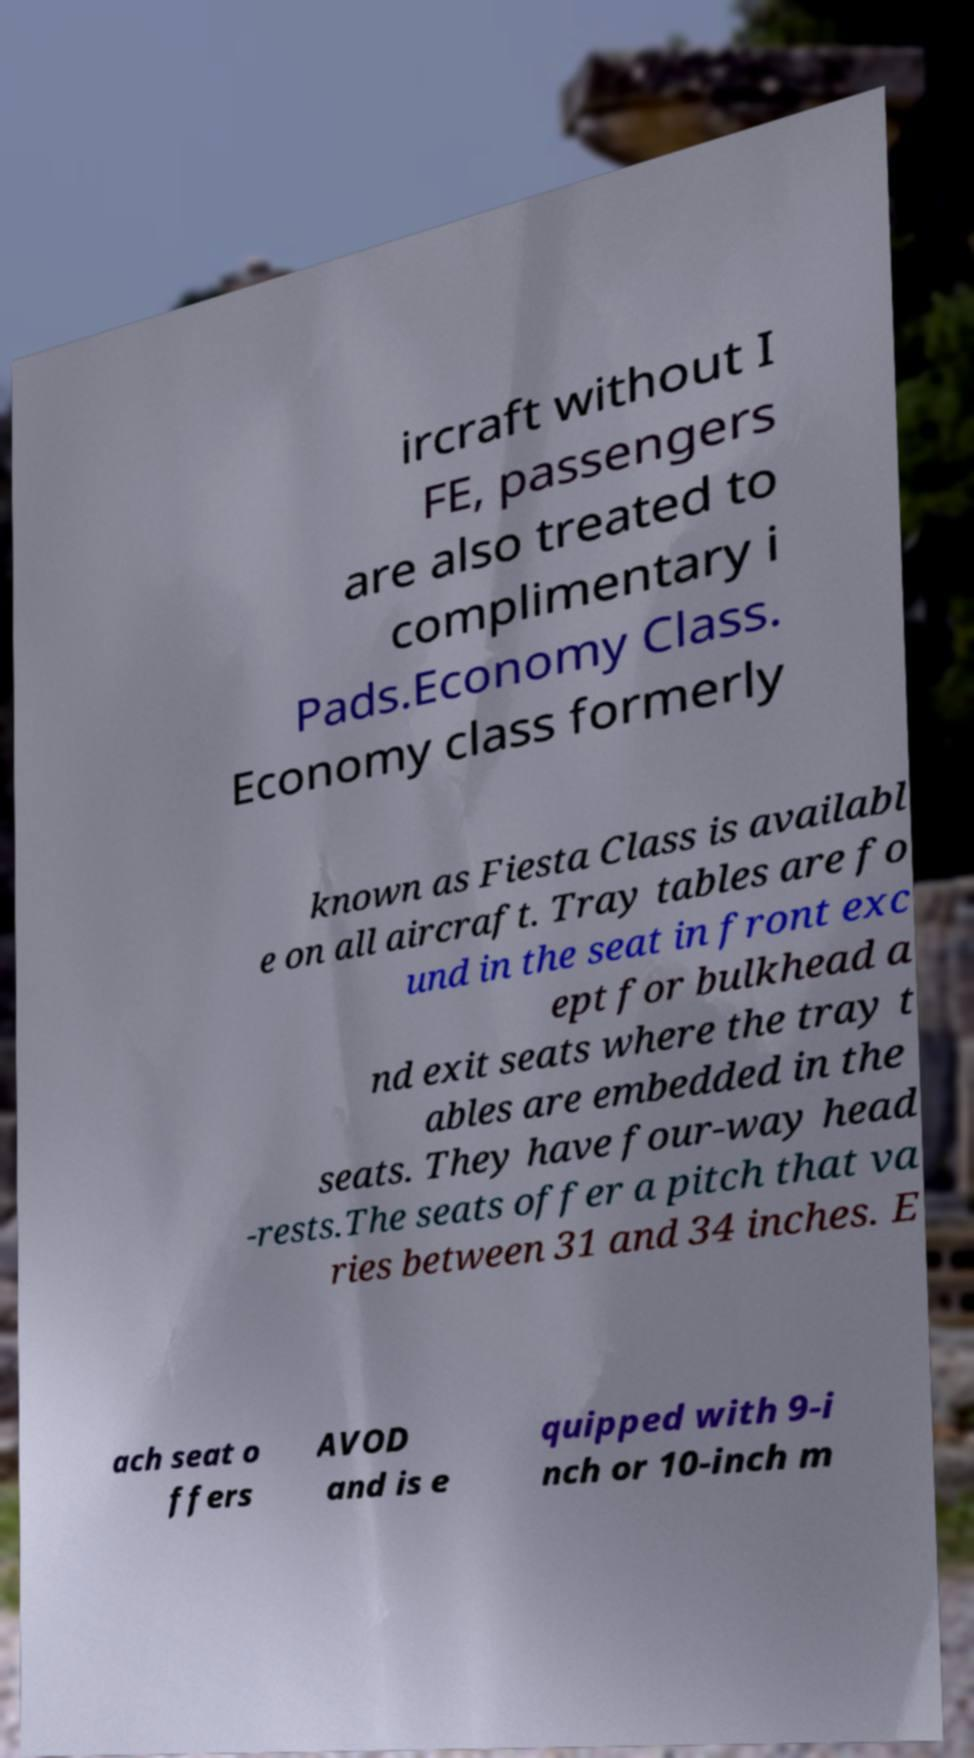For documentation purposes, I need the text within this image transcribed. Could you provide that? ircraft without I FE, passengers are also treated to complimentary i Pads.Economy Class. Economy class formerly known as Fiesta Class is availabl e on all aircraft. Tray tables are fo und in the seat in front exc ept for bulkhead a nd exit seats where the tray t ables are embedded in the seats. They have four-way head -rests.The seats offer a pitch that va ries between 31 and 34 inches. E ach seat o ffers AVOD and is e quipped with 9-i nch or 10-inch m 